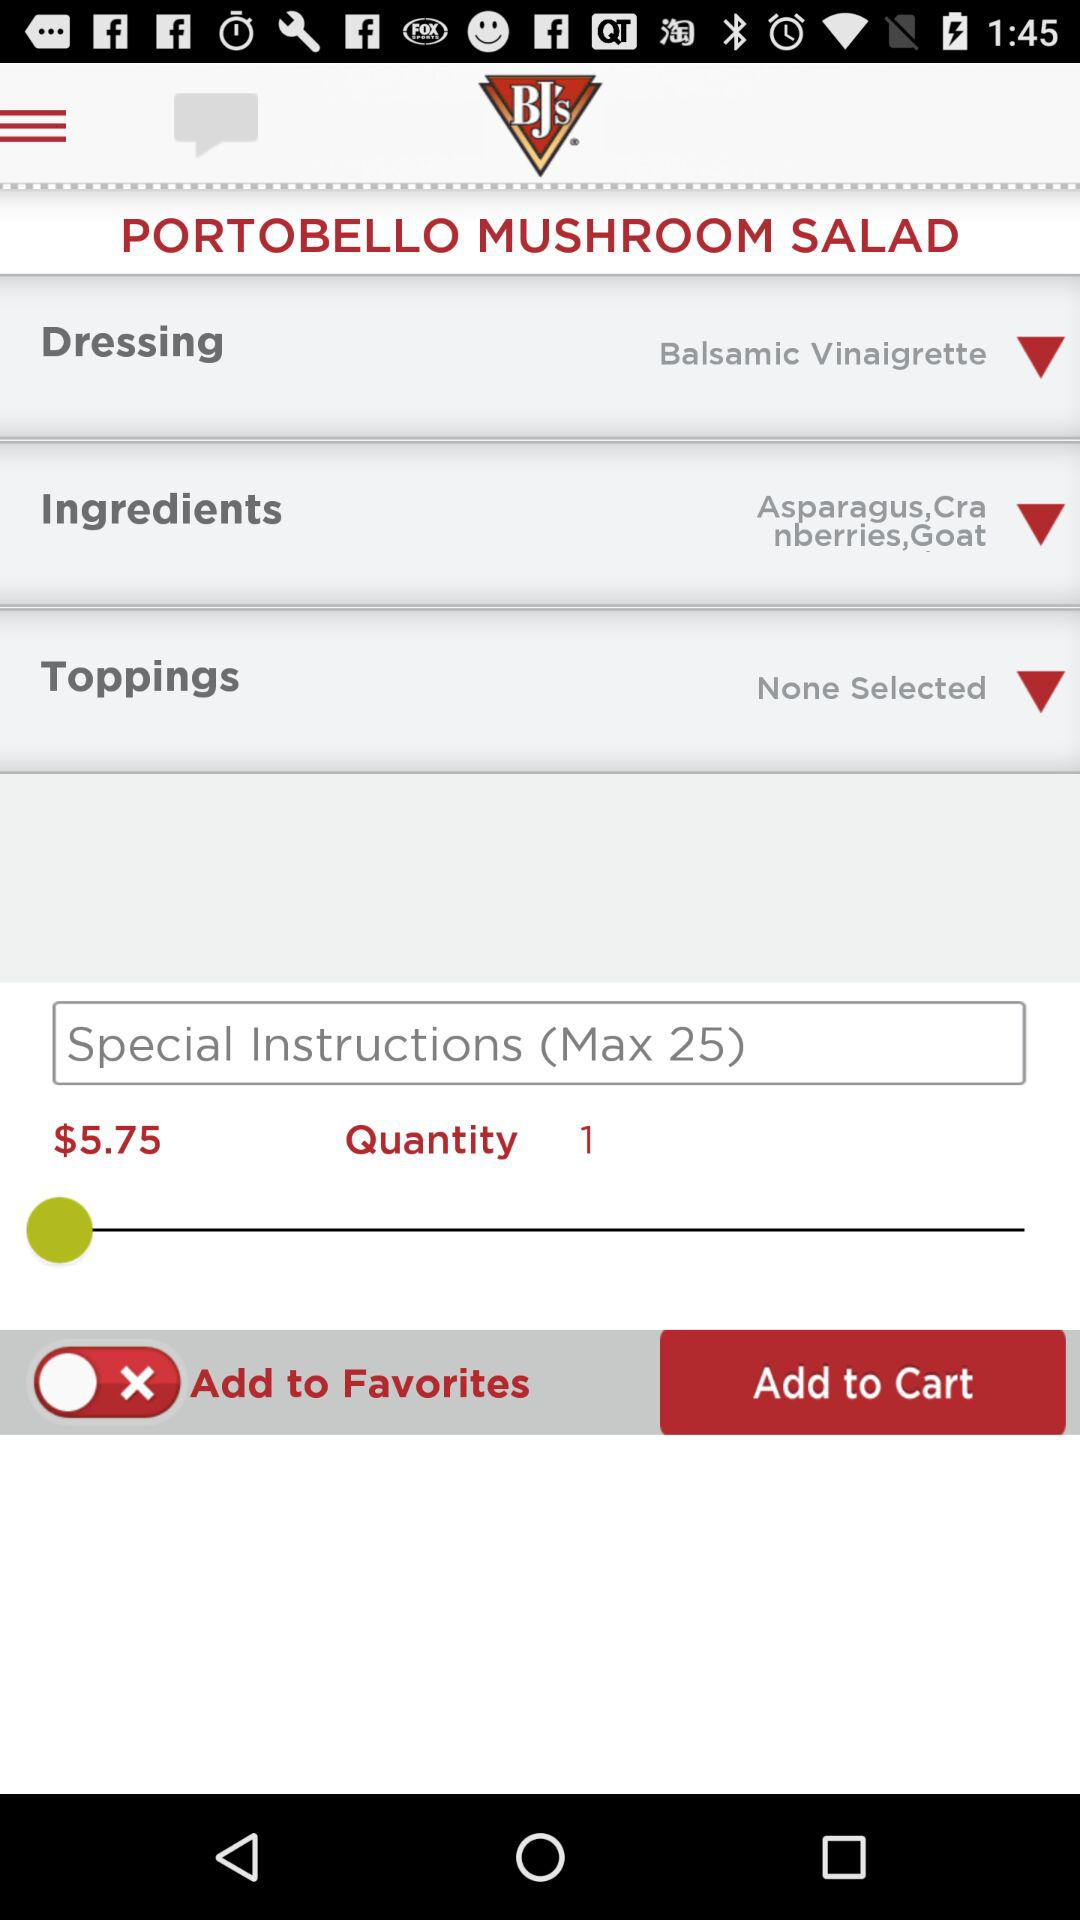What is the price of "PORTOBELLO MUSHROOM SALAD"? The price is $5.75. 